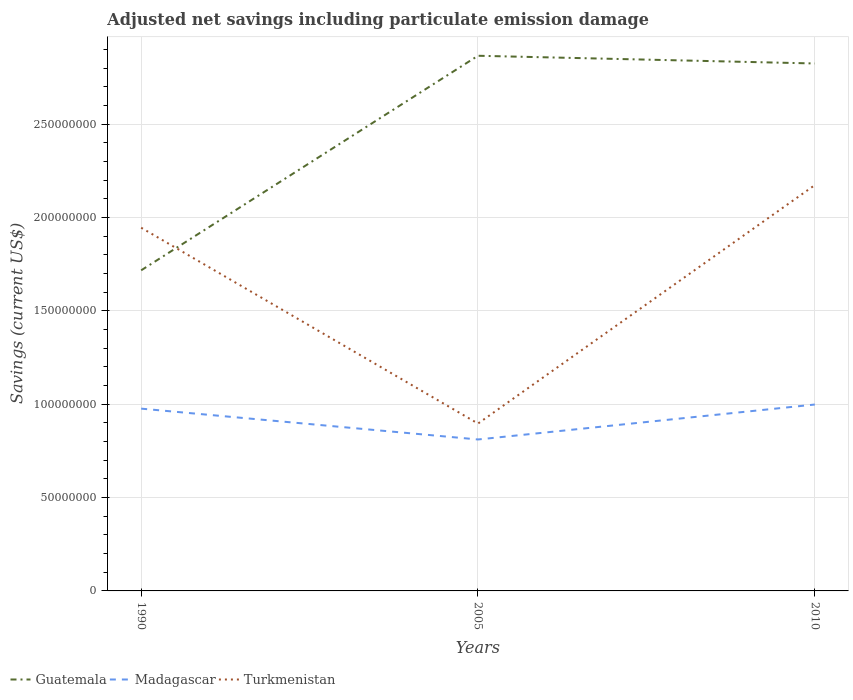Does the line corresponding to Guatemala intersect with the line corresponding to Madagascar?
Offer a very short reply. No. Across all years, what is the maximum net savings in Guatemala?
Keep it short and to the point. 1.72e+08. In which year was the net savings in Turkmenistan maximum?
Your response must be concise. 2005. What is the total net savings in Guatemala in the graph?
Your response must be concise. 4.13e+06. What is the difference between the highest and the second highest net savings in Madagascar?
Offer a very short reply. 1.87e+07. How many years are there in the graph?
Provide a succinct answer. 3. What is the difference between two consecutive major ticks on the Y-axis?
Make the answer very short. 5.00e+07. Are the values on the major ticks of Y-axis written in scientific E-notation?
Offer a very short reply. No. Does the graph contain any zero values?
Keep it short and to the point. No. Does the graph contain grids?
Offer a very short reply. Yes. How many legend labels are there?
Ensure brevity in your answer.  3. What is the title of the graph?
Provide a short and direct response. Adjusted net savings including particulate emission damage. Does "Jordan" appear as one of the legend labels in the graph?
Your answer should be compact. No. What is the label or title of the X-axis?
Offer a very short reply. Years. What is the label or title of the Y-axis?
Your response must be concise. Savings (current US$). What is the Savings (current US$) in Guatemala in 1990?
Keep it short and to the point. 1.72e+08. What is the Savings (current US$) of Madagascar in 1990?
Your response must be concise. 9.76e+07. What is the Savings (current US$) in Turkmenistan in 1990?
Offer a very short reply. 1.95e+08. What is the Savings (current US$) of Guatemala in 2005?
Offer a very short reply. 2.87e+08. What is the Savings (current US$) of Madagascar in 2005?
Offer a very short reply. 8.11e+07. What is the Savings (current US$) of Turkmenistan in 2005?
Make the answer very short. 8.96e+07. What is the Savings (current US$) in Guatemala in 2010?
Provide a short and direct response. 2.83e+08. What is the Savings (current US$) in Madagascar in 2010?
Your answer should be compact. 9.98e+07. What is the Savings (current US$) in Turkmenistan in 2010?
Provide a succinct answer. 2.17e+08. Across all years, what is the maximum Savings (current US$) of Guatemala?
Your answer should be very brief. 2.87e+08. Across all years, what is the maximum Savings (current US$) of Madagascar?
Provide a short and direct response. 9.98e+07. Across all years, what is the maximum Savings (current US$) of Turkmenistan?
Offer a very short reply. 2.17e+08. Across all years, what is the minimum Savings (current US$) in Guatemala?
Provide a short and direct response. 1.72e+08. Across all years, what is the minimum Savings (current US$) of Madagascar?
Your answer should be very brief. 8.11e+07. Across all years, what is the minimum Savings (current US$) in Turkmenistan?
Give a very brief answer. 8.96e+07. What is the total Savings (current US$) in Guatemala in the graph?
Offer a terse response. 7.41e+08. What is the total Savings (current US$) in Madagascar in the graph?
Ensure brevity in your answer.  2.79e+08. What is the total Savings (current US$) of Turkmenistan in the graph?
Ensure brevity in your answer.  5.02e+08. What is the difference between the Savings (current US$) in Guatemala in 1990 and that in 2005?
Provide a succinct answer. -1.15e+08. What is the difference between the Savings (current US$) of Madagascar in 1990 and that in 2005?
Keep it short and to the point. 1.65e+07. What is the difference between the Savings (current US$) of Turkmenistan in 1990 and that in 2005?
Your response must be concise. 1.05e+08. What is the difference between the Savings (current US$) of Guatemala in 1990 and that in 2010?
Provide a succinct answer. -1.11e+08. What is the difference between the Savings (current US$) in Madagascar in 1990 and that in 2010?
Provide a short and direct response. -2.20e+06. What is the difference between the Savings (current US$) in Turkmenistan in 1990 and that in 2010?
Your answer should be compact. -2.28e+07. What is the difference between the Savings (current US$) of Guatemala in 2005 and that in 2010?
Offer a terse response. 4.13e+06. What is the difference between the Savings (current US$) in Madagascar in 2005 and that in 2010?
Make the answer very short. -1.87e+07. What is the difference between the Savings (current US$) in Turkmenistan in 2005 and that in 2010?
Your answer should be very brief. -1.28e+08. What is the difference between the Savings (current US$) in Guatemala in 1990 and the Savings (current US$) in Madagascar in 2005?
Provide a short and direct response. 9.06e+07. What is the difference between the Savings (current US$) of Guatemala in 1990 and the Savings (current US$) of Turkmenistan in 2005?
Your answer should be compact. 8.21e+07. What is the difference between the Savings (current US$) in Madagascar in 1990 and the Savings (current US$) in Turkmenistan in 2005?
Offer a terse response. 7.99e+06. What is the difference between the Savings (current US$) of Guatemala in 1990 and the Savings (current US$) of Madagascar in 2010?
Offer a very short reply. 7.19e+07. What is the difference between the Savings (current US$) in Guatemala in 1990 and the Savings (current US$) in Turkmenistan in 2010?
Make the answer very short. -4.57e+07. What is the difference between the Savings (current US$) in Madagascar in 1990 and the Savings (current US$) in Turkmenistan in 2010?
Give a very brief answer. -1.20e+08. What is the difference between the Savings (current US$) in Guatemala in 2005 and the Savings (current US$) in Madagascar in 2010?
Give a very brief answer. 1.87e+08. What is the difference between the Savings (current US$) of Guatemala in 2005 and the Savings (current US$) of Turkmenistan in 2010?
Offer a very short reply. 6.93e+07. What is the difference between the Savings (current US$) of Madagascar in 2005 and the Savings (current US$) of Turkmenistan in 2010?
Provide a short and direct response. -1.36e+08. What is the average Savings (current US$) in Guatemala per year?
Offer a terse response. 2.47e+08. What is the average Savings (current US$) in Madagascar per year?
Offer a terse response. 9.29e+07. What is the average Savings (current US$) of Turkmenistan per year?
Your answer should be very brief. 1.67e+08. In the year 1990, what is the difference between the Savings (current US$) of Guatemala and Savings (current US$) of Madagascar?
Offer a terse response. 7.41e+07. In the year 1990, what is the difference between the Savings (current US$) of Guatemala and Savings (current US$) of Turkmenistan?
Give a very brief answer. -2.28e+07. In the year 1990, what is the difference between the Savings (current US$) in Madagascar and Savings (current US$) in Turkmenistan?
Your answer should be compact. -9.69e+07. In the year 2005, what is the difference between the Savings (current US$) of Guatemala and Savings (current US$) of Madagascar?
Keep it short and to the point. 2.06e+08. In the year 2005, what is the difference between the Savings (current US$) in Guatemala and Savings (current US$) in Turkmenistan?
Provide a short and direct response. 1.97e+08. In the year 2005, what is the difference between the Savings (current US$) of Madagascar and Savings (current US$) of Turkmenistan?
Your answer should be compact. -8.53e+06. In the year 2010, what is the difference between the Savings (current US$) of Guatemala and Savings (current US$) of Madagascar?
Offer a terse response. 1.83e+08. In the year 2010, what is the difference between the Savings (current US$) in Guatemala and Savings (current US$) in Turkmenistan?
Provide a short and direct response. 6.51e+07. In the year 2010, what is the difference between the Savings (current US$) of Madagascar and Savings (current US$) of Turkmenistan?
Ensure brevity in your answer.  -1.18e+08. What is the ratio of the Savings (current US$) in Guatemala in 1990 to that in 2005?
Offer a terse response. 0.6. What is the ratio of the Savings (current US$) in Madagascar in 1990 to that in 2005?
Your response must be concise. 1.2. What is the ratio of the Savings (current US$) in Turkmenistan in 1990 to that in 2005?
Your response must be concise. 2.17. What is the ratio of the Savings (current US$) of Guatemala in 1990 to that in 2010?
Ensure brevity in your answer.  0.61. What is the ratio of the Savings (current US$) of Madagascar in 1990 to that in 2010?
Your response must be concise. 0.98. What is the ratio of the Savings (current US$) of Turkmenistan in 1990 to that in 2010?
Give a very brief answer. 0.89. What is the ratio of the Savings (current US$) of Guatemala in 2005 to that in 2010?
Provide a succinct answer. 1.01. What is the ratio of the Savings (current US$) of Madagascar in 2005 to that in 2010?
Keep it short and to the point. 0.81. What is the ratio of the Savings (current US$) of Turkmenistan in 2005 to that in 2010?
Provide a short and direct response. 0.41. What is the difference between the highest and the second highest Savings (current US$) of Guatemala?
Keep it short and to the point. 4.13e+06. What is the difference between the highest and the second highest Savings (current US$) in Madagascar?
Keep it short and to the point. 2.20e+06. What is the difference between the highest and the second highest Savings (current US$) of Turkmenistan?
Your response must be concise. 2.28e+07. What is the difference between the highest and the lowest Savings (current US$) of Guatemala?
Provide a succinct answer. 1.15e+08. What is the difference between the highest and the lowest Savings (current US$) in Madagascar?
Keep it short and to the point. 1.87e+07. What is the difference between the highest and the lowest Savings (current US$) of Turkmenistan?
Offer a terse response. 1.28e+08. 